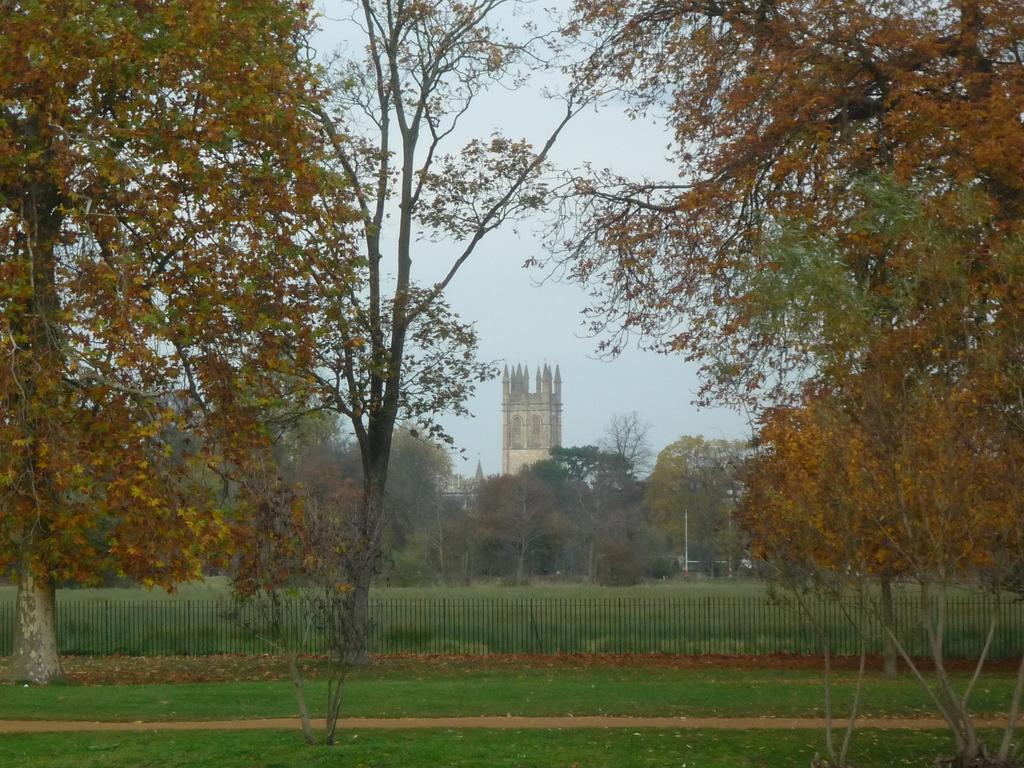Can you describe this image briefly? In this image there is a grass on the ground beside that there is a fence and trees, also there is a building in between the trees. 